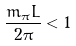Convert formula to latex. <formula><loc_0><loc_0><loc_500><loc_500>\frac { m _ { \pi } L } { 2 \pi } < 1</formula> 